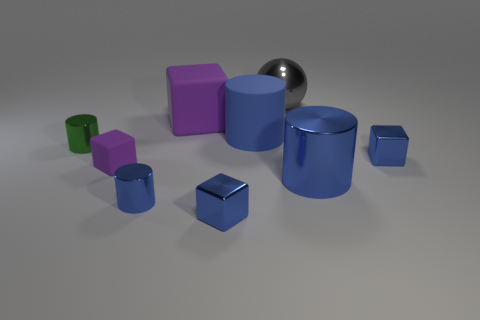Subtract all purple blocks. How many blue cylinders are left? 3 Subtract all blue cubes. Subtract all brown cylinders. How many cubes are left? 2 Add 1 small objects. How many objects exist? 10 Subtract all cylinders. How many objects are left? 5 Subtract 1 purple blocks. How many objects are left? 8 Subtract all big blue rubber cylinders. Subtract all large blue cylinders. How many objects are left? 6 Add 2 big purple things. How many big purple things are left? 3 Add 9 gray things. How many gray things exist? 10 